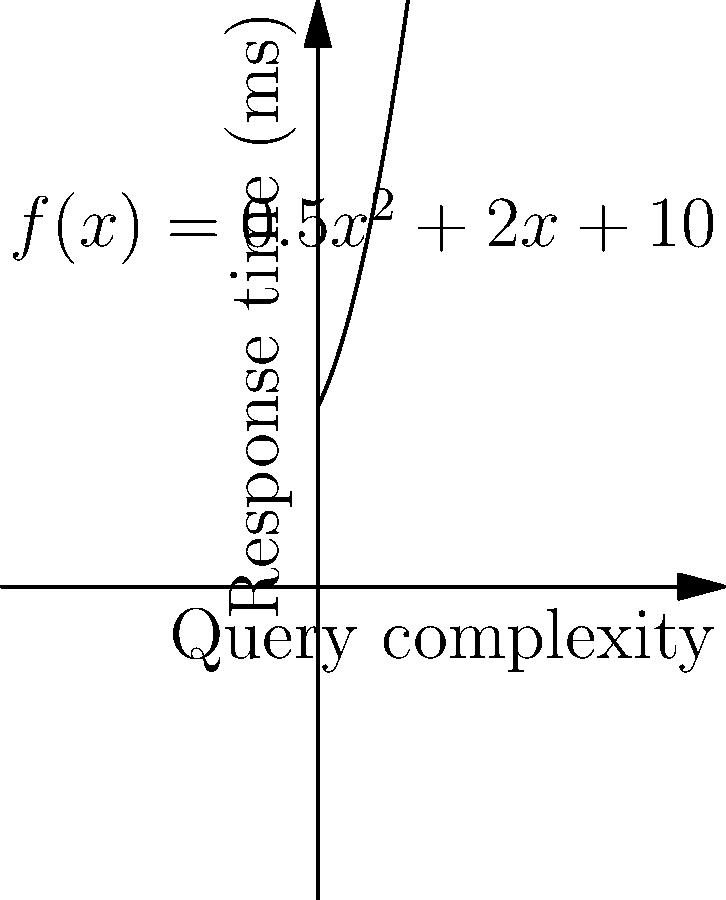As a DBA, you're optimizing a database query. The response time (in milliseconds) is modeled by the function $f(x) = 0.5x^2 + 2x + 10$, where $x$ represents the query complexity. At what query complexity does the rate of change in response time equal 5 ms per unit of complexity? To solve this problem, we need to follow these steps:

1) The rate of change is represented by the derivative of the function. Let's find $f'(x)$:

   $f'(x) = (0.5x^2 + 2x + 10)'$
   $f'(x) = x + 2$

2) We want to find where this rate of change equals 5 ms per unit of complexity. So, we set up the equation:

   $f'(x) = 5$
   $x + 2 = 5$

3) Now we solve for x:

   $x = 5 - 2$
   $x = 3$

4) To verify, we can plug this back into $f'(x)$:

   $f'(3) = 3 + 2 = 5$

This confirms that when $x = 3$, the rate of change is indeed 5 ms per unit of complexity.
Answer: 3 